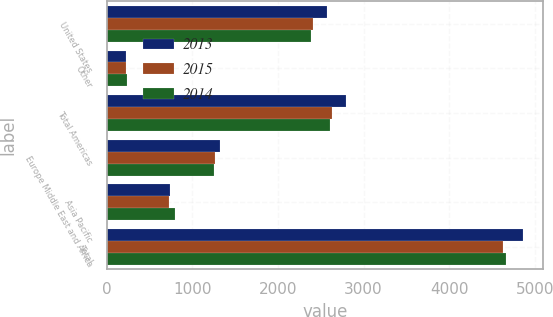<chart> <loc_0><loc_0><loc_500><loc_500><stacked_bar_chart><ecel><fcel>United States<fcel>Other<fcel>Total Americas<fcel>Europe Middle East and Africa<fcel>Asia Pacific<fcel>Total<nl><fcel>2013<fcel>2568.6<fcel>223.6<fcel>2792.2<fcel>1320.3<fcel>745.3<fcel>4857.8<nl><fcel>2015<fcel>2410.6<fcel>219.7<fcel>2630.3<fcel>1263.3<fcel>733.5<fcel>4627.1<nl><fcel>2014<fcel>2381.5<fcel>232<fcel>2613.5<fcel>1256.9<fcel>798.7<fcel>4669.1<nl></chart> 